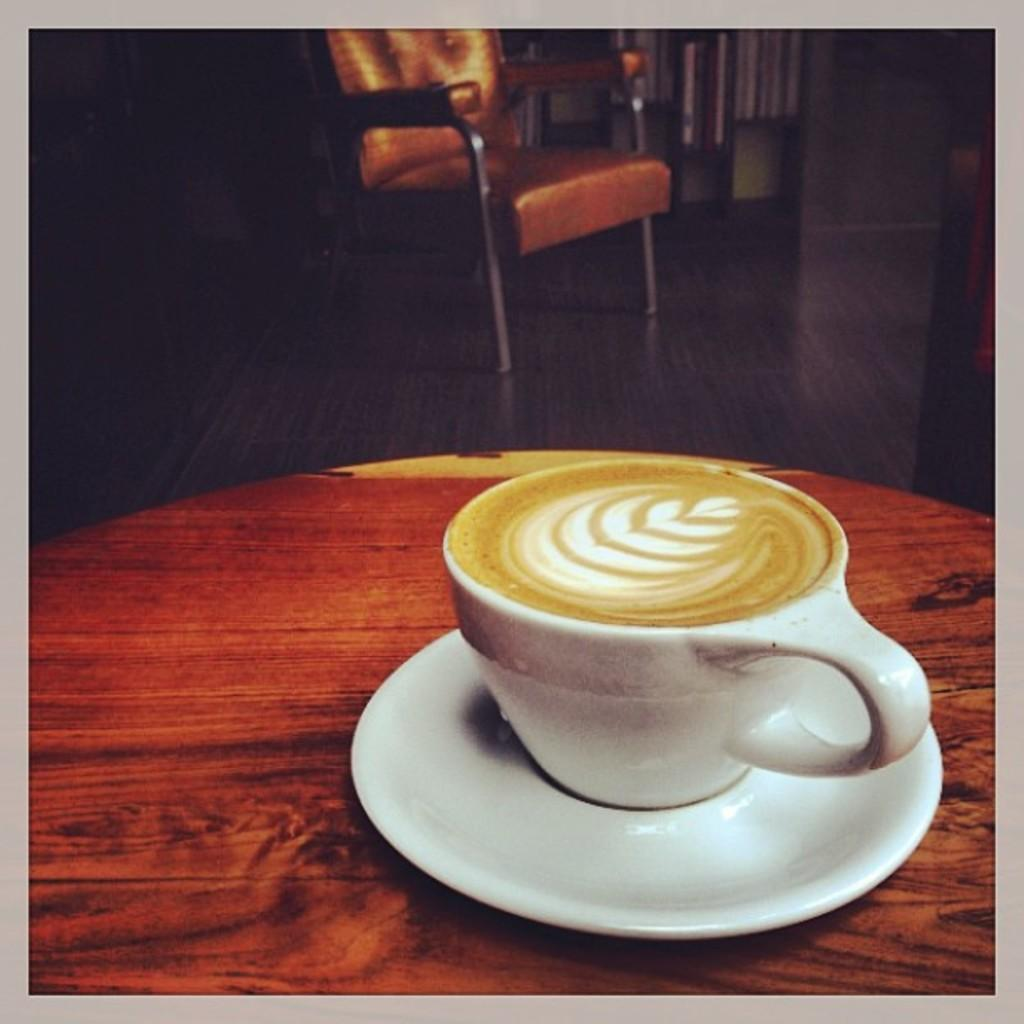What is on the table in the image? There is a tea cup on a saucer on the table in the image. What is the relationship between the tea cup and the saucer? The tea cup is on the saucer. Where is the tea cup and saucer located in relation to the table? Both the tea cup and saucer are on the table. What piece of furniture is visible in the image? There is a chair visible in the image. How many beads are on the chair in the image? There are no beads visible on the chair in the image. 